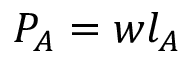Convert formula to latex. <formula><loc_0><loc_0><loc_500><loc_500>P _ { A } = w l _ { A }</formula> 